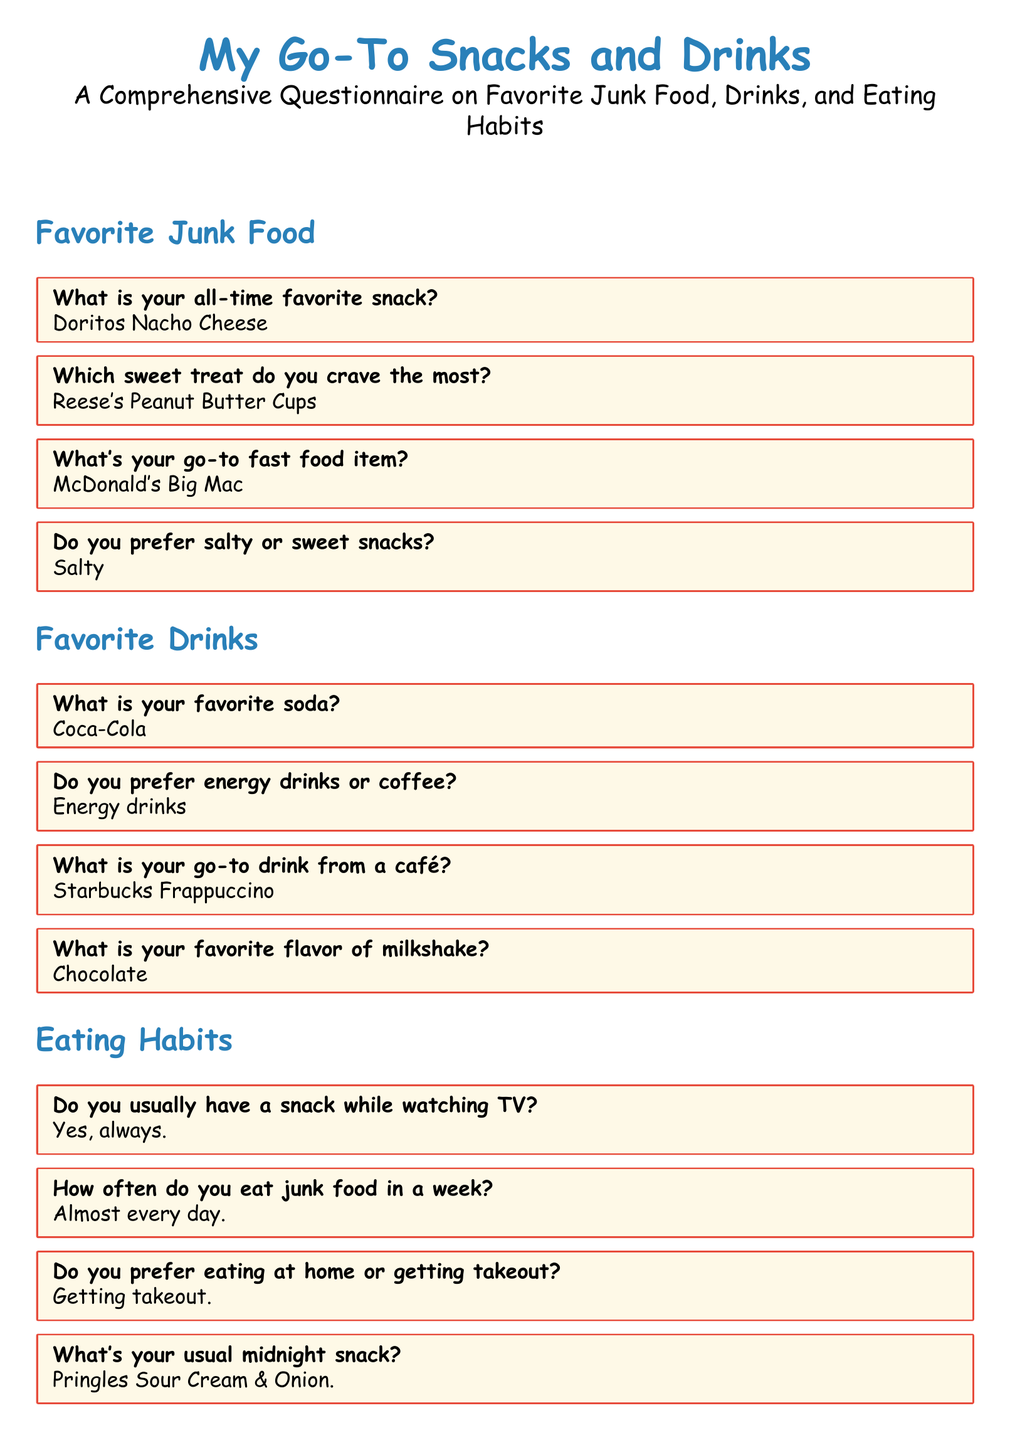What is the all-time favorite snack? The document specifically lists "Doritos Nacho Cheese" as the all-time favorite snack.
Answer: Doritos Nacho Cheese Which sweet treat is craved the most? The questionnaire indicates "Reese's Peanut Butter Cups" as the sweet treat most craved.
Answer: Reese's Peanut Butter Cups How often is junk food eaten in a week? According to the document, the response states junk food is eaten "Almost every day."
Answer: Almost every day What is the usual midnight snack listed? The questionnaire specifies "Pringles Sour Cream & Onion" as the usual midnight snack.
Answer: Pringles Sour Cream & Onion Which drink is preferred from a café? The document notes that the go-to drink from a café is a "Starbucks Frappuccino."
Answer: Starbucks Frappuccino What is the favorite flavor of milkshake? Based on the document, the favorite milkshake flavor is "Chocolate."
Answer: Chocolate Do they prefer salty or sweet snacks? According to the questionnaire, the preference is for "Salty" snacks.
Answer: Salty What is the favorite soda mentioned? The document specifies "Coca-Cola" as the favorite soda.
Answer: Coca-Cola What fast food item is the go-to choice? The document lists "McDonald's Big Mac" as the go-to fast food item.
Answer: McDonald's Big Mac 